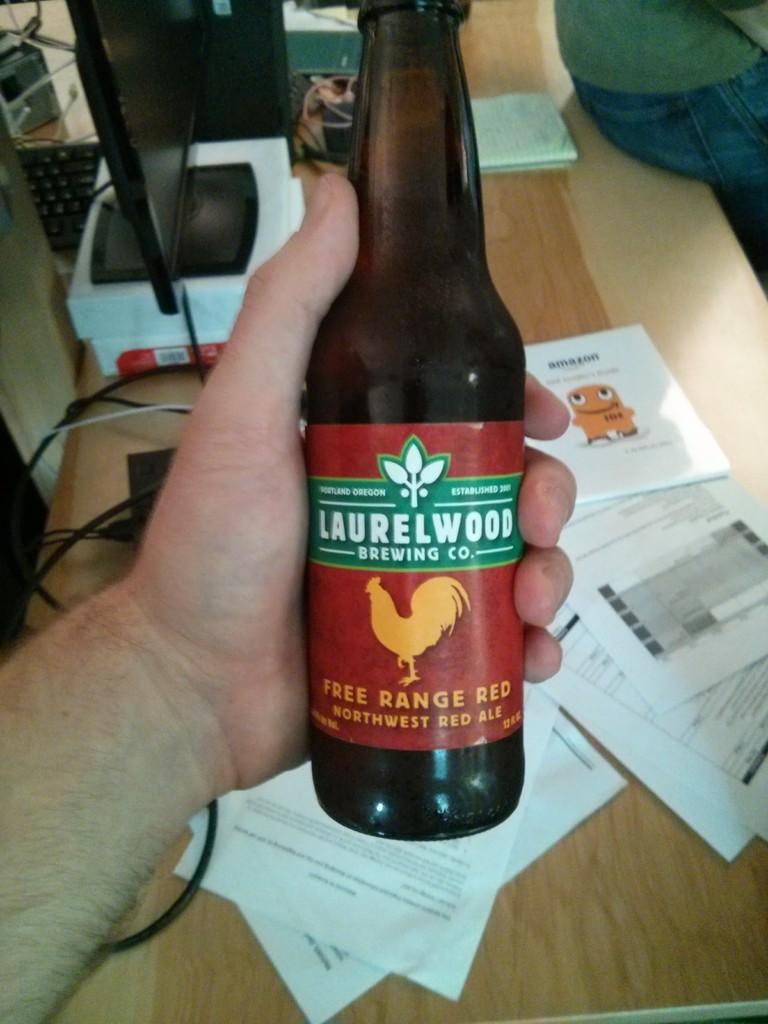What is the name of the beer?
Make the answer very short. Laurelwood. What is the name of the brewery that produced this beer?
Make the answer very short. Laurelwood. 